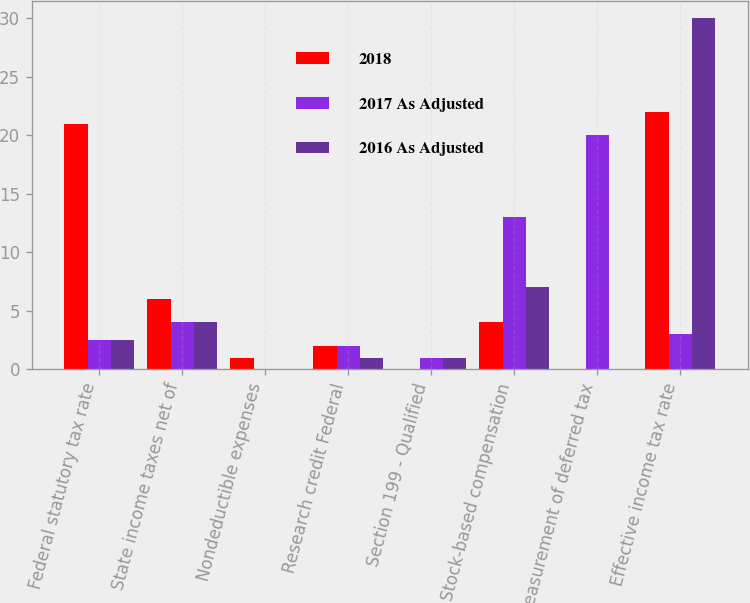Convert chart to OTSL. <chart><loc_0><loc_0><loc_500><loc_500><stacked_bar_chart><ecel><fcel>Federal statutory tax rate<fcel>State income taxes net of<fcel>Nondeductible expenses<fcel>Research credit Federal<fcel>Section 199 - Qualified<fcel>Stock-based compensation<fcel>Remeasurement of deferred tax<fcel>Effective income tax rate<nl><fcel>2018<fcel>21<fcel>6<fcel>1<fcel>2<fcel>0<fcel>4<fcel>0<fcel>22<nl><fcel>2017 As Adjusted<fcel>2.5<fcel>4<fcel>0<fcel>2<fcel>1<fcel>13<fcel>20<fcel>3<nl><fcel>2016 As Adjusted<fcel>2.5<fcel>4<fcel>0<fcel>1<fcel>1<fcel>7<fcel>0<fcel>30<nl></chart> 